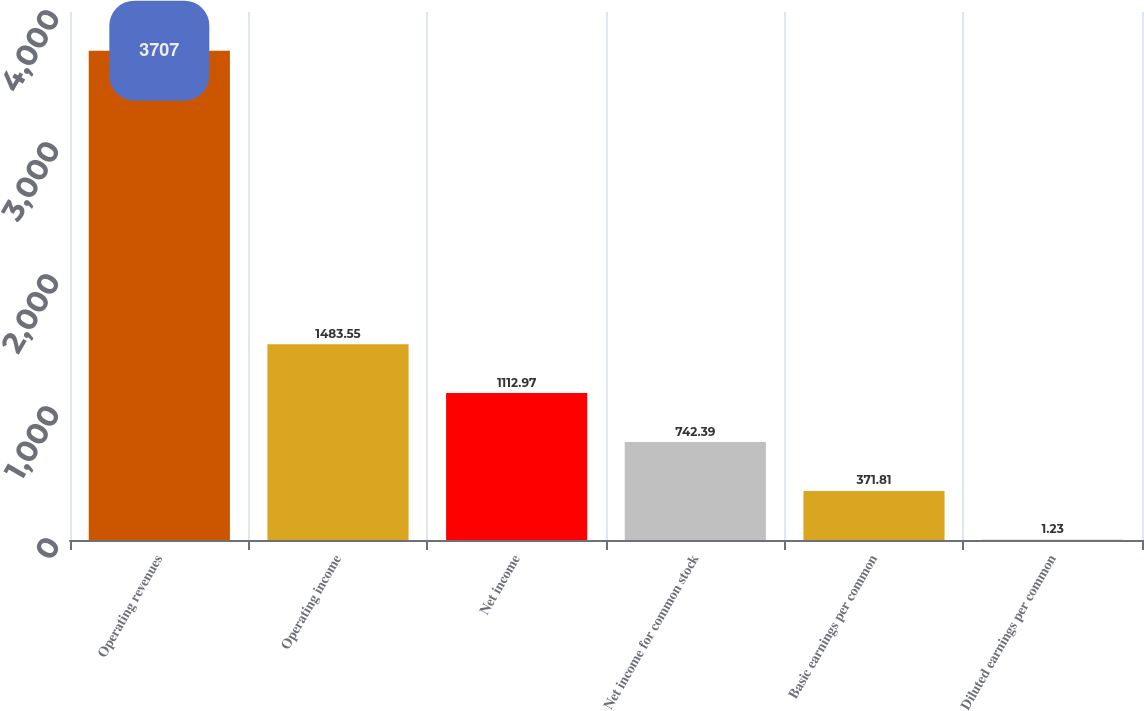Convert chart. <chart><loc_0><loc_0><loc_500><loc_500><bar_chart><fcel>Operating revenues<fcel>Operating income<fcel>Net income<fcel>Net income for common stock<fcel>Basic earnings per common<fcel>Diluted earnings per common<nl><fcel>3707<fcel>1483.55<fcel>1112.97<fcel>742.39<fcel>371.81<fcel>1.23<nl></chart> 